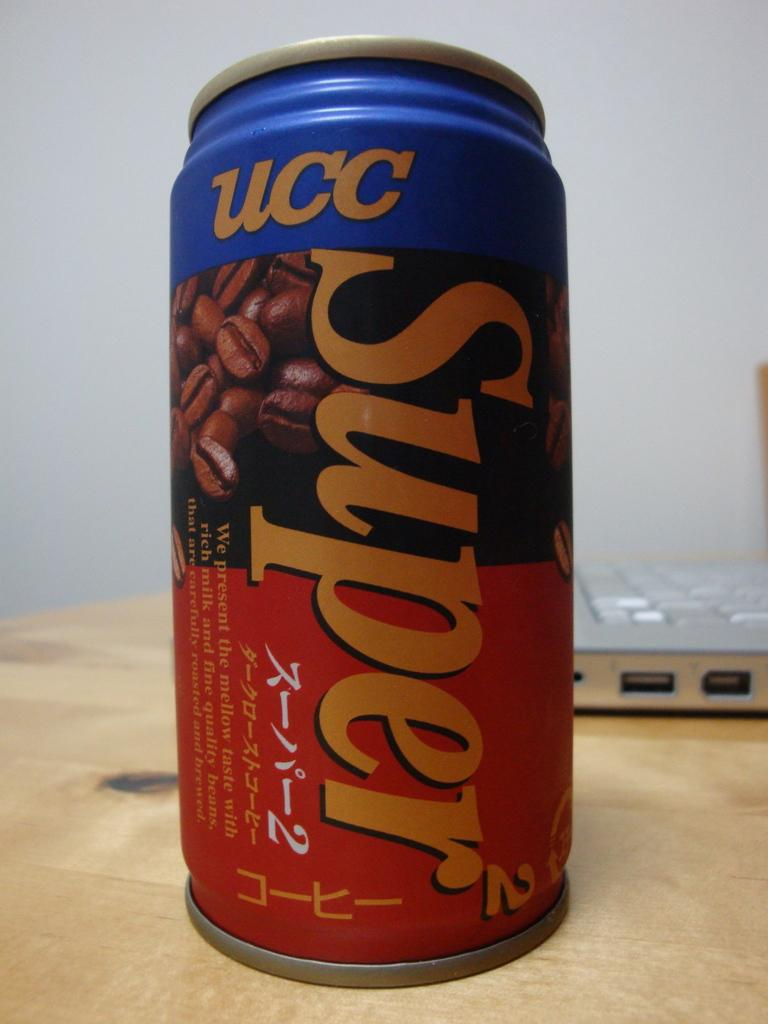<image>
Share a concise interpretation of the image provided. A can of UCC Super has a picture of coffee beans on it. 